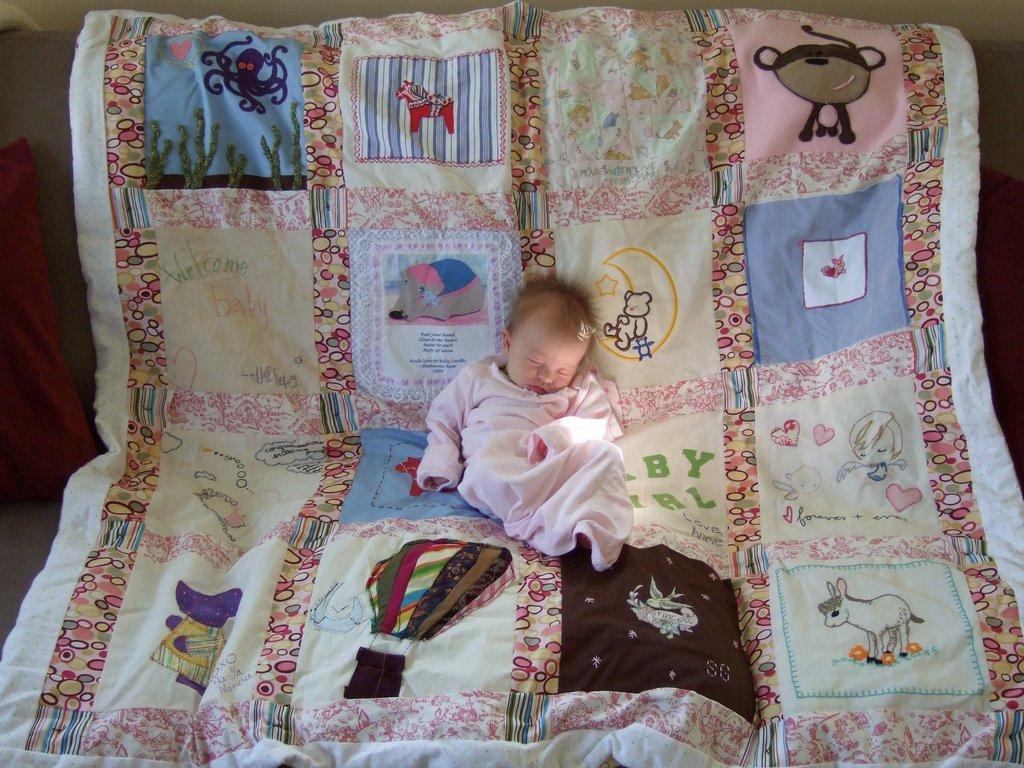Could you give a brief overview of what you see in this image? In this image I can see the child sleeping on the cloth which is colorful. To the left I can see the pillow. These are on the grey color surface. In the background I can see the wall. 